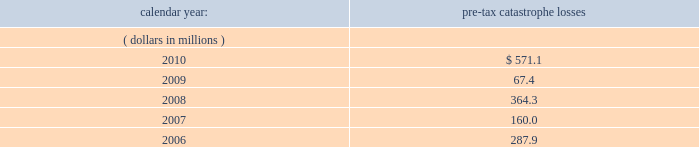United kingdom .
Bermuda re 2019s uk branch conducts business in the uk and is subject to taxation in the uk .
Bermuda re believes that it has operated and will continue to operate its bermuda operation in a manner which will not cause them to be subject to uk taxation .
If bermuda re 2019s bermuda operations were to become subject to uk income tax , there could be a material adverse impact on the company 2019s financial condition , results of operations and cash flow .
Ireland .
Holdings ireland and ireland re conduct business in ireland and are subject to taxation in ireland .
Available information .
The company 2019s annual reports on form 10-k , quarterly reports on form 10-q , current reports on form 8- k , proxy statements and amendments to those reports are available free of charge through the company 2019s internet website at http://www.everestre.com as soon as reasonably practicable after such reports are electronically filed with the securities and exchange commission ( the 201csec 201d ) .
Item 1a .
Risk factors in addition to the other information provided in this report , the following risk factors should be considered when evaluating an investment in our securities .
If the circumstances contemplated by the individual risk factors materialize , our business , financial condition and results of operations could be materially and adversely affected and the trading price of our common shares could decline significantly .
Risks relating to our business fluctuations in the financial markets could result in investment losses .
Prolonged and severe disruptions in the public debt and equity markets , such as occurred during 2008 , could result in significant realized and unrealized losses in our investment portfolio .
For the year ended december 31 , 2008 , we incurred $ 695.8 million of realized investment gains and $ 310.4 million of unrealized investment losses .
Although financial markets significantly improved during 2009 and 2010 , they could deteriorate in the future and again result in substantial realized and unrealized losses , which could have a material adverse impact on our results of operations , equity , business and insurer financial strength and debt ratings .
Our results could be adversely affected by catastrophic events .
We are exposed to unpredictable catastrophic events , including weather-related and other natural catastrophes , as well as acts of terrorism .
Any material reduction in our operating results caused by the occurrence of one or more catastrophes could inhibit our ability to pay dividends or to meet our interest and principal payment obligations .
Subsequent to april 1 , 2010 , we define a catastrophe as an event that causes a loss on property exposures before reinsurance of at least $ 10.0 million , before corporate level reinsurance and taxes .
Prior to april 1 , 2010 , we used a threshold of $ 5.0 million .
By way of illustration , during the past five calendar years , pre-tax catastrophe losses , net of contract specific reinsurance but before cessions under corporate reinsurance programs , were as follows: .

What is the percent change in pre tax catastrophe losses between 2007 and 2008? 
Computations: ((364.3 - 160.0) / 160.0)
Answer: 1.27687. 